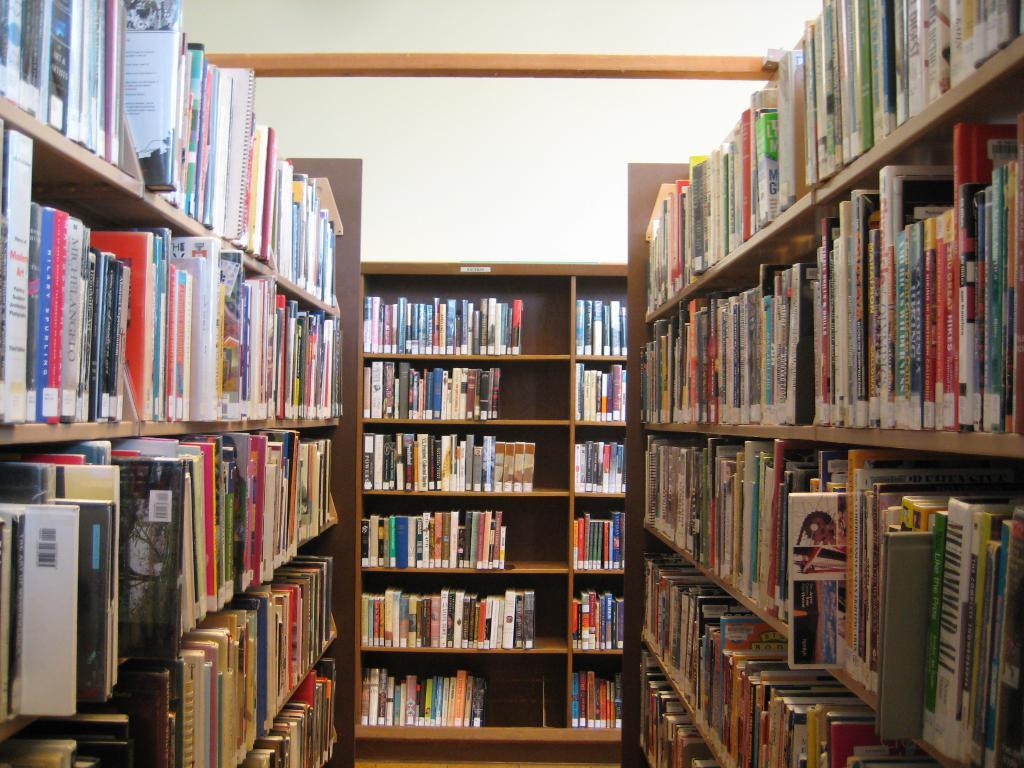What objects can be seen in the image? There are books in the image. Where are the books located? The books are in shelves. What type of suit is hanging on the bookshelf in the image? There is no suit present in the image; it only features books in shelves. 